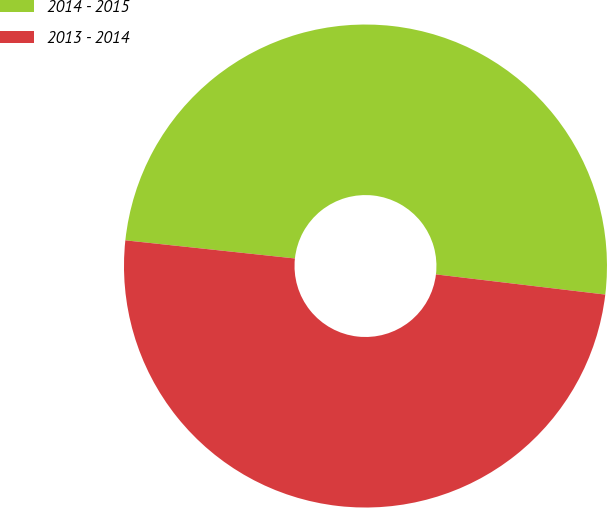Convert chart. <chart><loc_0><loc_0><loc_500><loc_500><pie_chart><fcel>2014 - 2015<fcel>2013 - 2014<nl><fcel>50.19%<fcel>49.81%<nl></chart> 